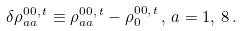<formula> <loc_0><loc_0><loc_500><loc_500>\delta \rho ^ { 0 0 , \, t } _ { a a } \equiv \rho ^ { 0 0 , \, t } _ { a a } - \rho ^ { 0 0 , \, t } _ { 0 } \, , \, a = 1 , \, 8 \, .</formula> 